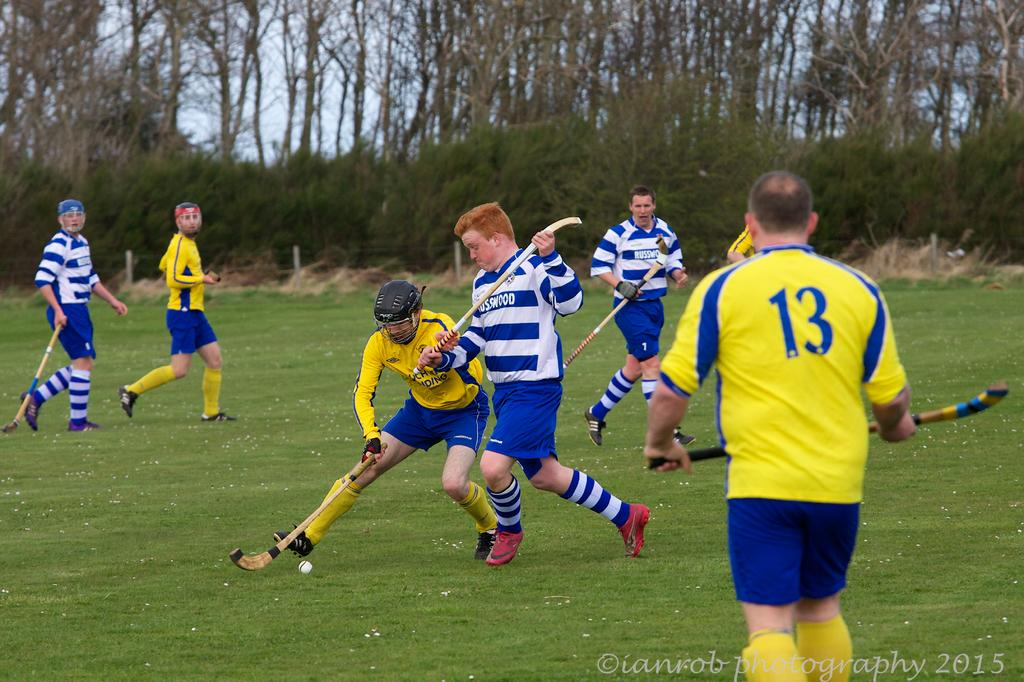<image>
Relay a brief, clear account of the picture shown. A man with a shirt with number 13 looks on at two players on the field. 